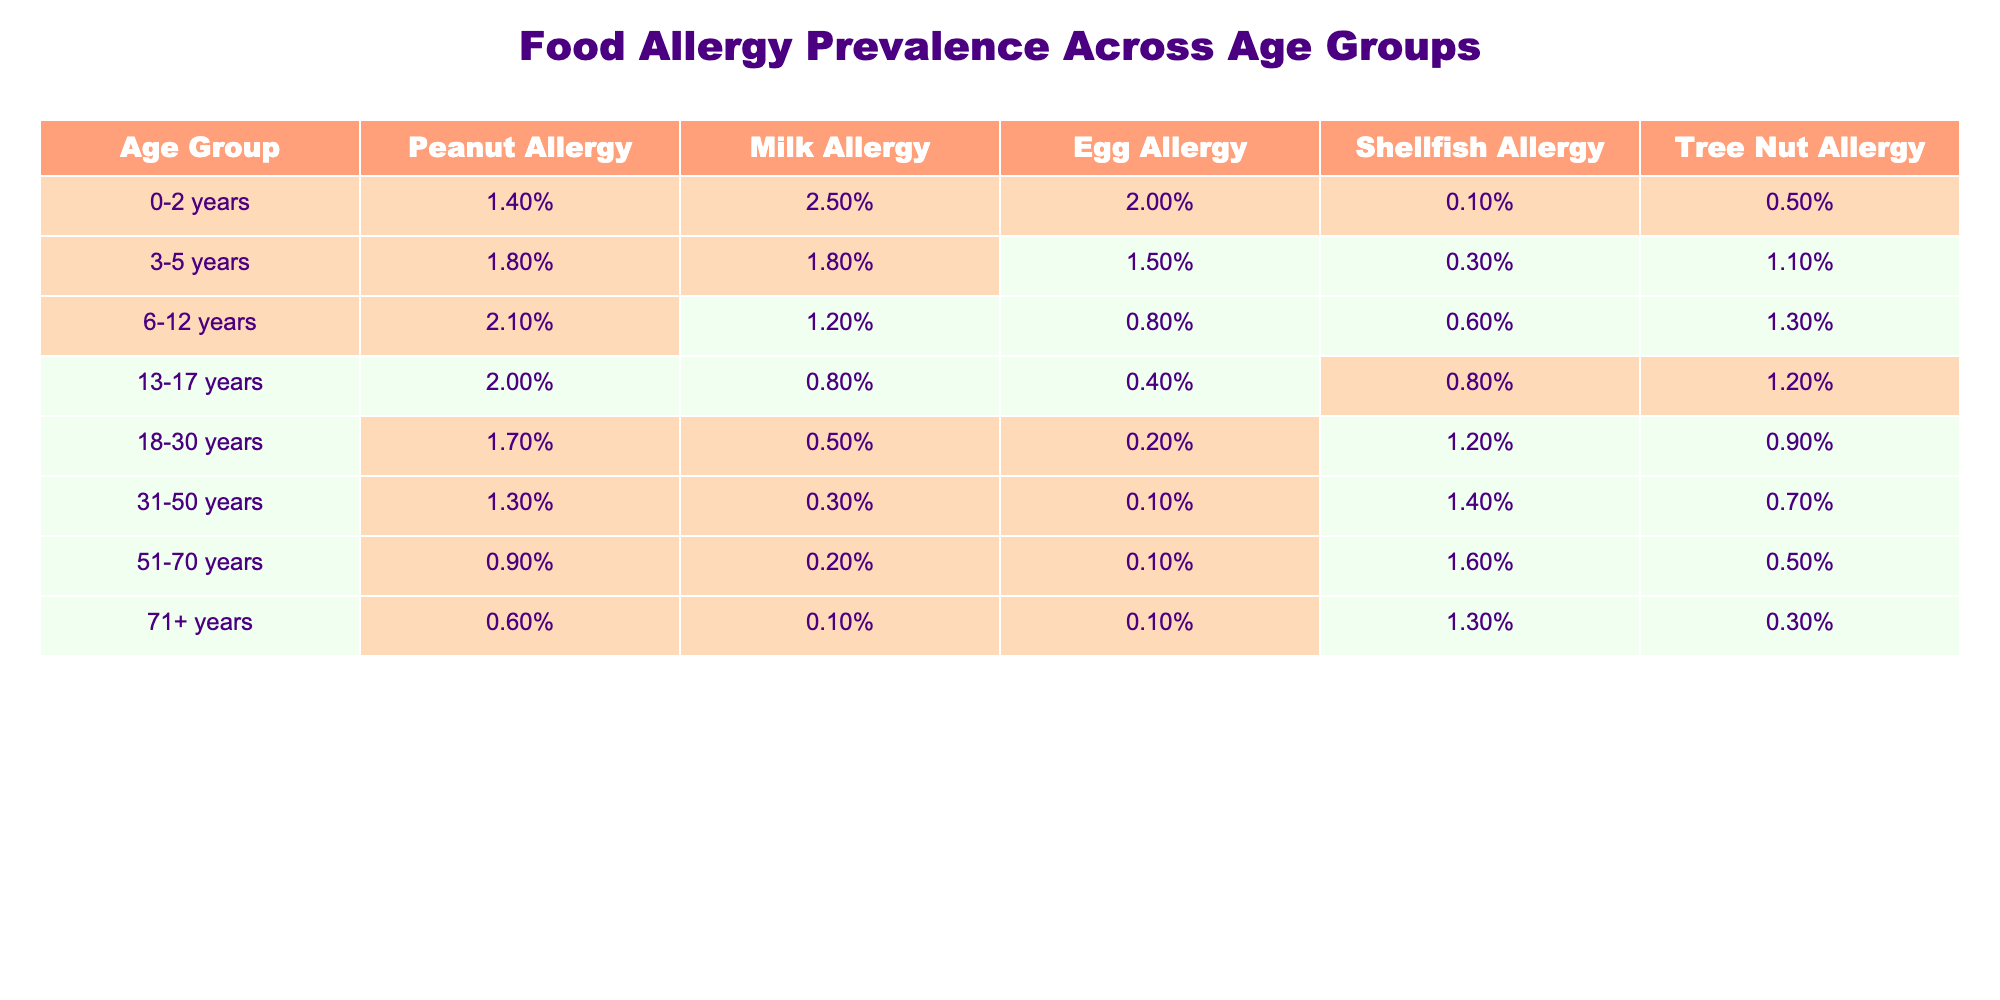What is the prevalence of milk allergy in the 0-2 years age group? The table indicates that the prevalence of milk allergy in the 0-2 years age group is 2.5%.
Answer: 2.5% Which age group has the highest prevalence of peanut allergy? By scanning the table, the age group 6-12 years has the highest prevalence of peanut allergy at 2.1%.
Answer: 6-12 years What is the difference in prevalence of egg allergy between the 3-5 years and 51-70 years age groups? The prevalence of egg allergy in the 3-5 years age group is 1.5% while in the 51-70 years age group it is 0.1%. The difference is calculated as 1.5% - 0.1% = 1.4%.
Answer: 1.4% Is the prevalence of tree nut allergy in the 31-50 years age group greater than in the 18-30 years age group? The table shows that the prevalence of tree nut allergy is 0.7% in the 31-50 years age group and 0.9% in the 18-30 years age group, so it is not greater.
Answer: No What is the prevalence of shellfish allergy in individuals aged 71 years and older? According to the table, the prevalence of shellfish allergy in the 71+ years age group is 1.3%.
Answer: 1.3% What is the average prevalence of peanut allergy across all age groups listed in the table? To find the average, sum the prevalence values: 1.4% + 1.8% + 2.1% + 2.0% + 1.7% + 1.3% + 0.9% + 0.6% = 11.8%. There are 8 age groups, so divide by 8: 11.8% / 8 = 1.475%.
Answer: 1.48% Which age group has the lowest prevalence for shellfish allergy? The table shows that the age group 0-2 years has the lowest prevalence for shellfish allergy at 0.1%.
Answer: 0-2 years Is there an increase or decrease in the prevalence of milk allergy as age increases, based on the table? Observing the table, the prevalence of milk allergy decreases as the age groups increase, from 2.5% in 0-2 years to 0.1% in 71+ years.
Answer: Decrease What is the total prevalence of allergies to peanut, milk, and egg in the 13-17 years age group? In the 13-17 years age group, the allergy prevalences are: peanut 2.0%, milk 0.8%, and egg 0.4%. The total is calculated as 2.0% + 0.8% + 0.4% = 3.2%.
Answer: 3.2% 